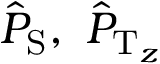Convert formula to latex. <formula><loc_0><loc_0><loc_500><loc_500>{ \hat { P } } _ { { S } } , \ { \hat { P } } _ { { T } _ { z } }</formula> 